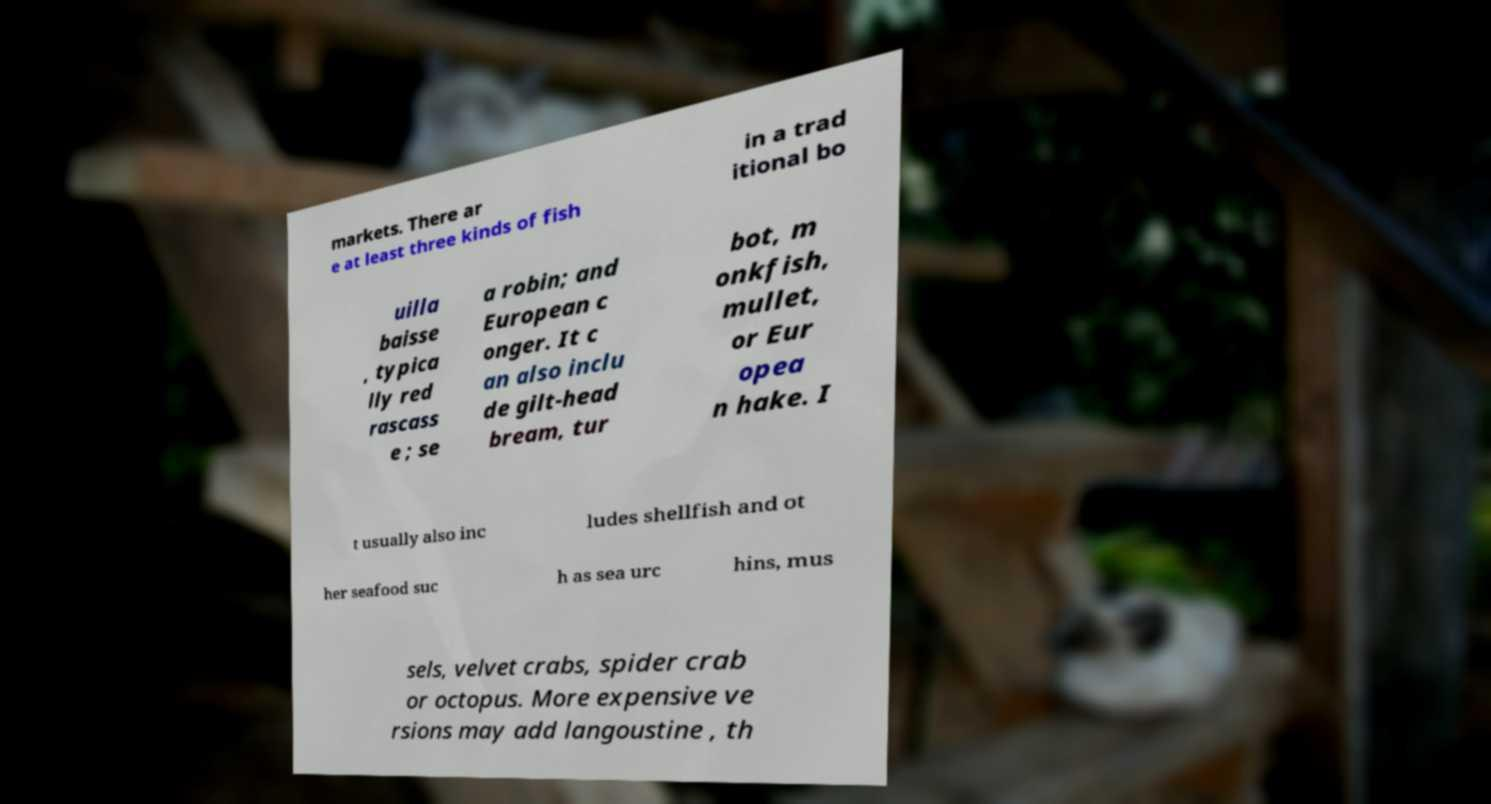Please identify and transcribe the text found in this image. markets. There ar e at least three kinds of fish in a trad itional bo uilla baisse , typica lly red rascass e ; se a robin; and European c onger. It c an also inclu de gilt-head bream, tur bot, m onkfish, mullet, or Eur opea n hake. I t usually also inc ludes shellfish and ot her seafood suc h as sea urc hins, mus sels, velvet crabs, spider crab or octopus. More expensive ve rsions may add langoustine , th 